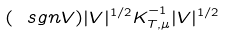<formula> <loc_0><loc_0><loc_500><loc_500>( \ s g n V ) | V | ^ { 1 / 2 } K _ { T , \mu } ^ { - 1 } | V | ^ { 1 / 2 }</formula> 